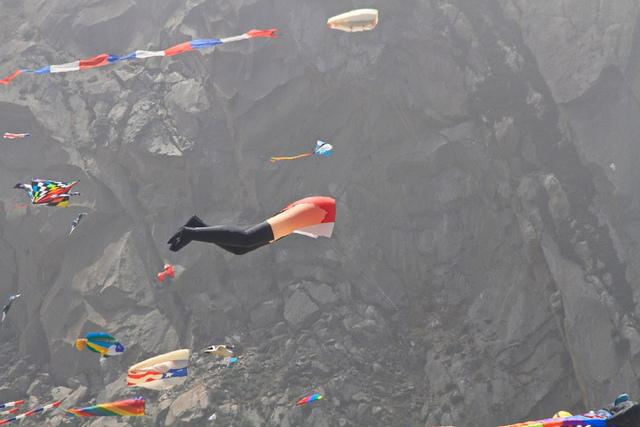What is the most popular kite shape? diamond 